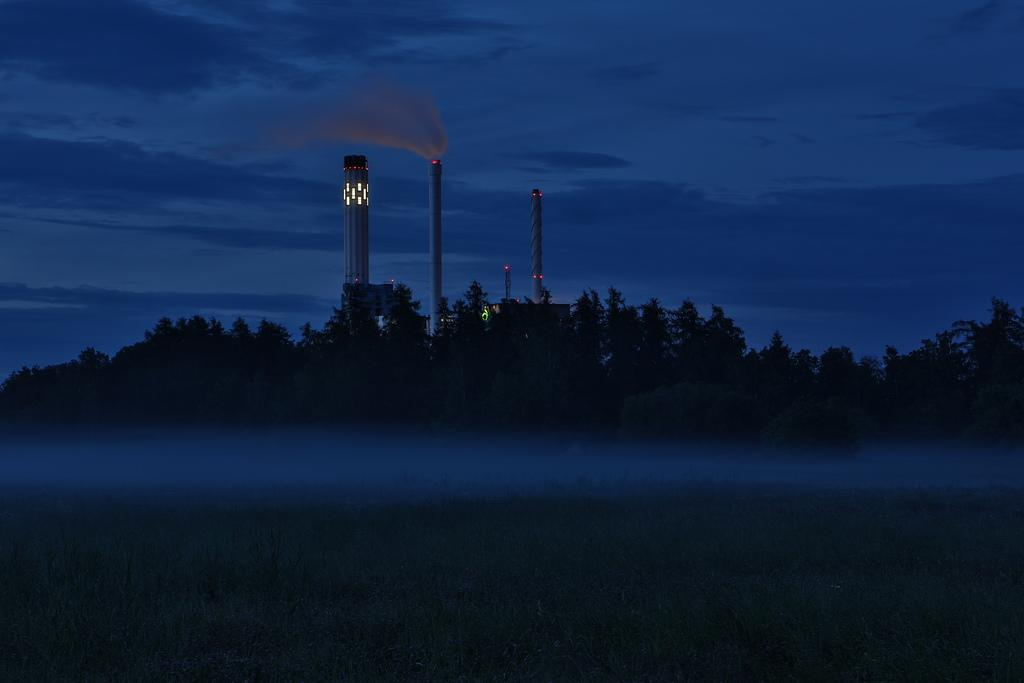What type of natural elements can be seen in the image? There are trees in the image. What structures are visible in the background of the image? There are three towers in the background of the image. What feature do the towers have in common? The towers have lights on them. What type of reward is being offered to the person who finds the lost interest in the image? There is no mention of a reward, loss, or interest in the image; it only features trees and three towers with lights. 